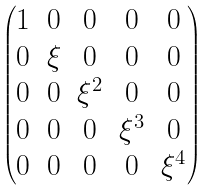<formula> <loc_0><loc_0><loc_500><loc_500>\begin{pmatrix} 1 & 0 & 0 & 0 & 0 \\ 0 & \xi & 0 & 0 & 0 \\ 0 & 0 & \xi ^ { 2 } & 0 & 0 \\ 0 & 0 & 0 & \xi ^ { 3 } & 0 \\ 0 & 0 & 0 & 0 & \xi ^ { 4 } \end{pmatrix}</formula> 